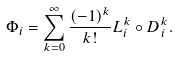<formula> <loc_0><loc_0><loc_500><loc_500>\Phi _ { i } = \sum _ { k = 0 } ^ { \infty } \frac { ( - 1 ) ^ { k } } { k ! } L _ { i } ^ { k } \circ D _ { i } ^ { k } .</formula> 